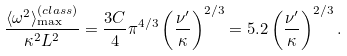<formula> <loc_0><loc_0><loc_500><loc_500>\frac { \langle \omega ^ { 2 } \rangle _ { \max } ^ { ( c l a s s ) } } { \kappa ^ { 2 } L ^ { 2 } } = \frac { 3 C } { 4 } \pi ^ { 4 / 3 } \left ( \frac { \nu ^ { \prime } } { \kappa } \right ) ^ { 2 / 3 } = 5 . 2 \left ( \frac { \nu ^ { \prime } } { \kappa } \right ) ^ { 2 / 3 } .</formula> 